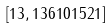Convert formula to latex. <formula><loc_0><loc_0><loc_500><loc_500>[ 1 3 , 1 3 6 1 0 1 5 2 1 ]</formula> 